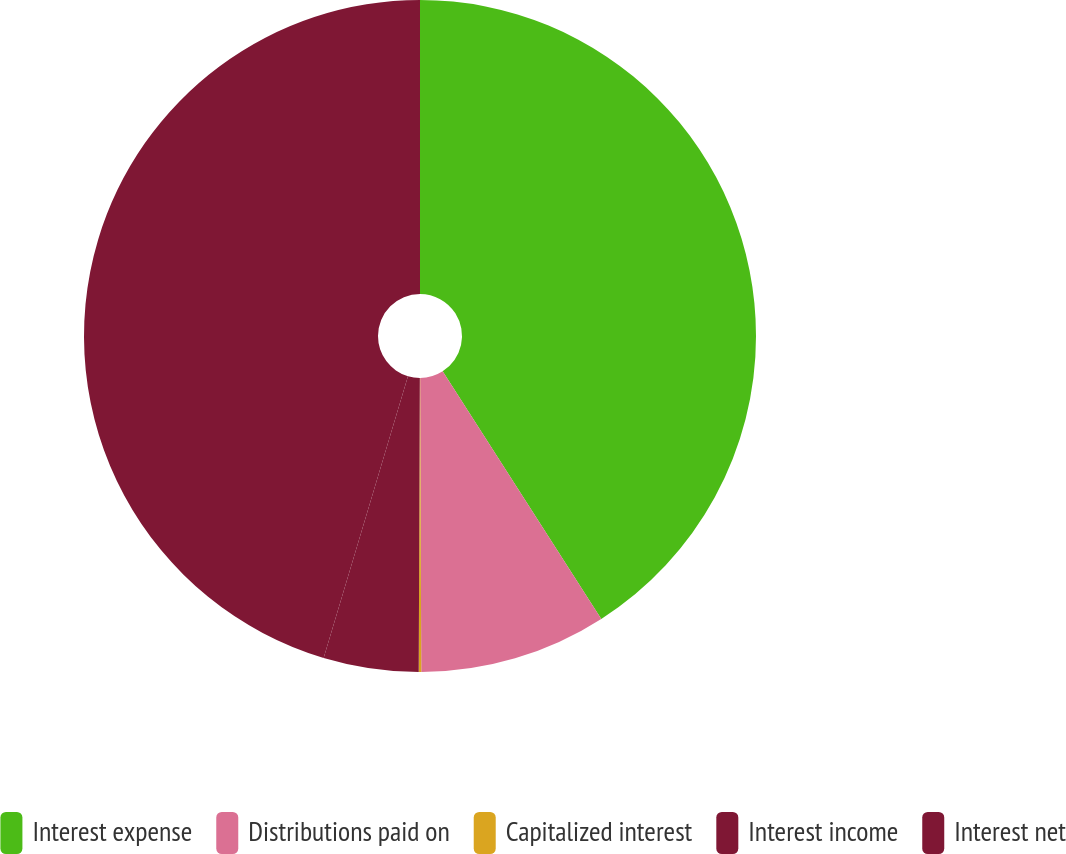Convert chart to OTSL. <chart><loc_0><loc_0><loc_500><loc_500><pie_chart><fcel>Interest expense<fcel>Distributions paid on<fcel>Capitalized interest<fcel>Interest income<fcel>Interest net<nl><fcel>40.93%<fcel>9.01%<fcel>0.12%<fcel>4.57%<fcel>45.37%<nl></chart> 